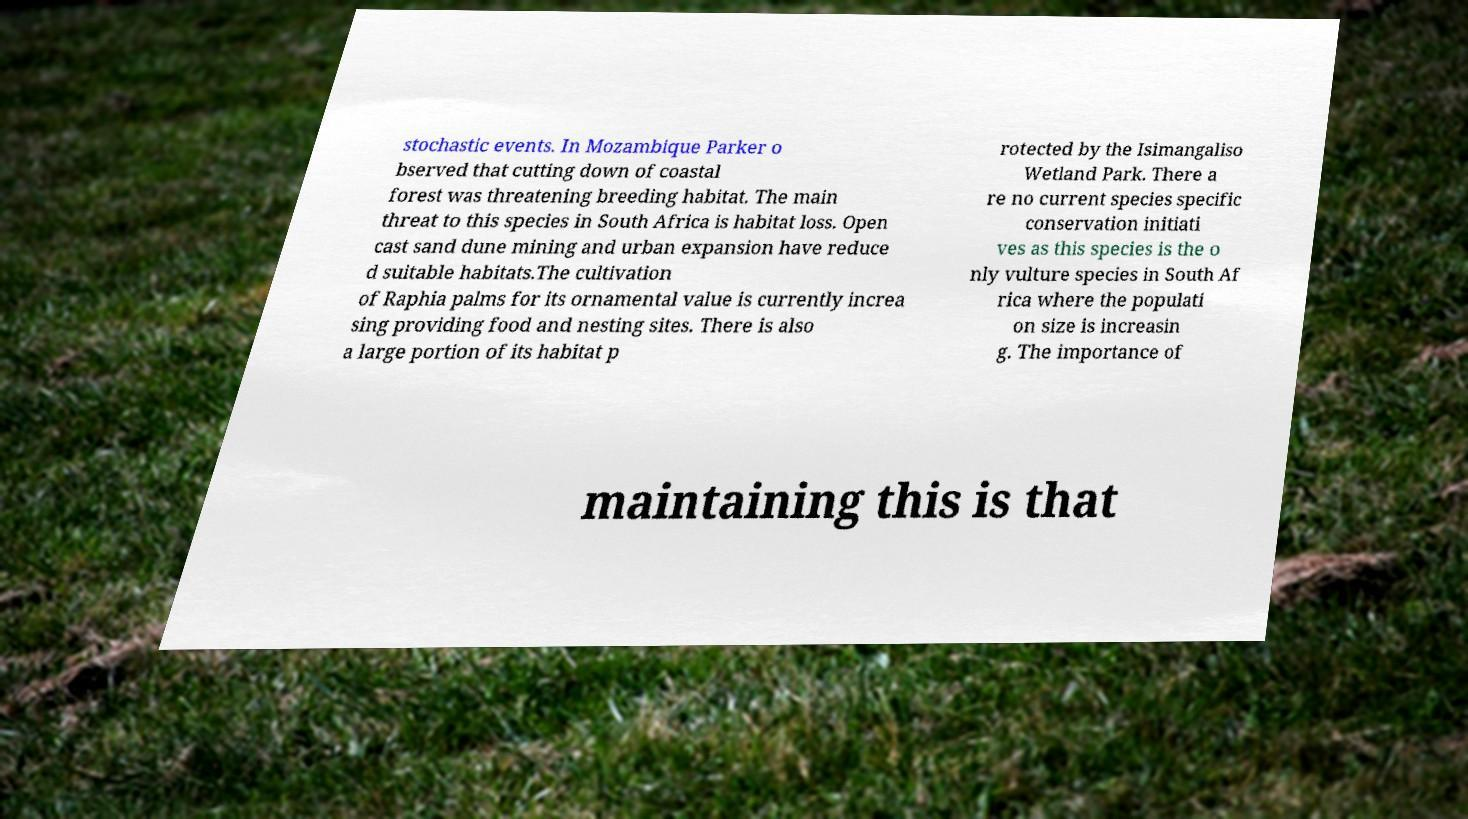For documentation purposes, I need the text within this image transcribed. Could you provide that? stochastic events. In Mozambique Parker o bserved that cutting down of coastal forest was threatening breeding habitat. The main threat to this species in South Africa is habitat loss. Open cast sand dune mining and urban expansion have reduce d suitable habitats.The cultivation of Raphia palms for its ornamental value is currently increa sing providing food and nesting sites. There is also a large portion of its habitat p rotected by the Isimangaliso Wetland Park. There a re no current species specific conservation initiati ves as this species is the o nly vulture species in South Af rica where the populati on size is increasin g. The importance of maintaining this is that 